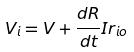Convert formula to latex. <formula><loc_0><loc_0><loc_500><loc_500>V _ { i } = V + \frac { d R } { d t } I r _ { i o }</formula> 